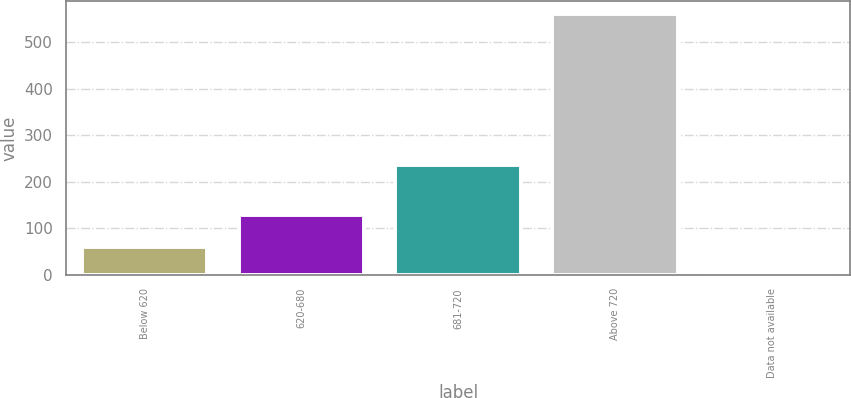Convert chart. <chart><loc_0><loc_0><loc_500><loc_500><bar_chart><fcel>Below 620<fcel>620-680<fcel>681-720<fcel>Above 720<fcel>Data not available<nl><fcel>60.6<fcel>129<fcel>236<fcel>561<fcel>5<nl></chart> 